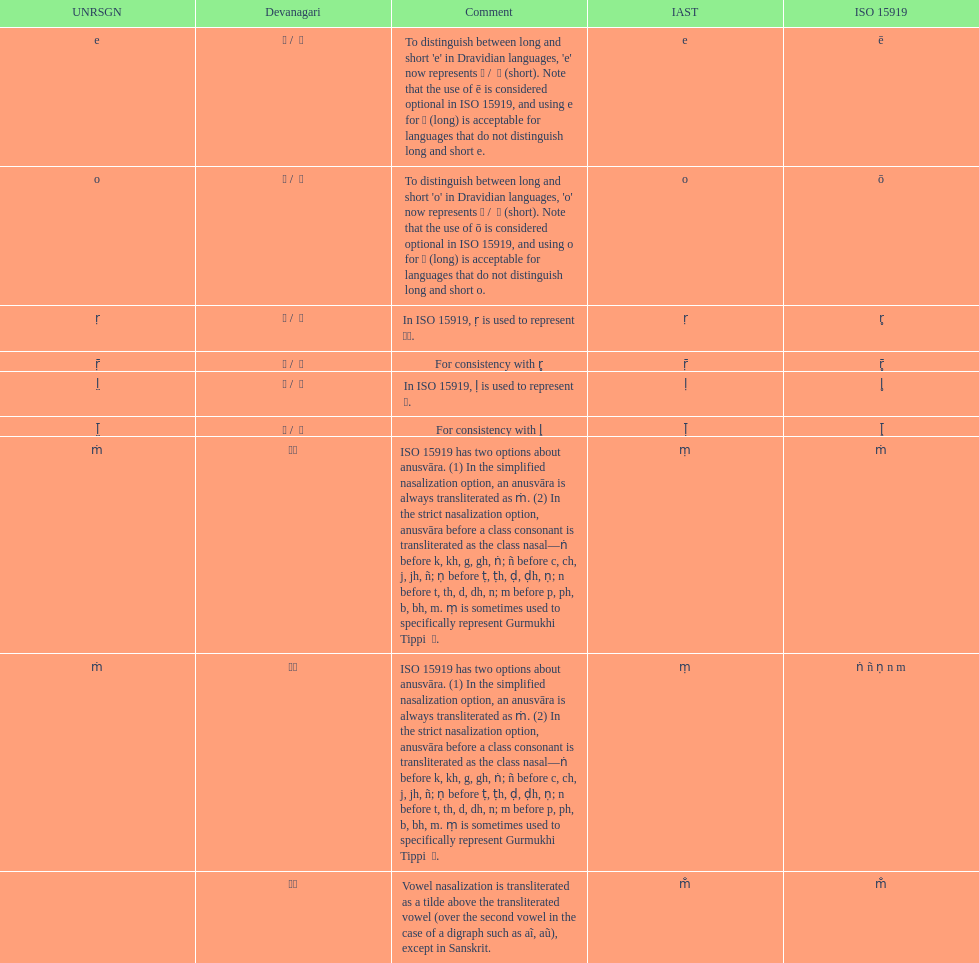Which devanagari transliteration is listed on the top of the table? ए / े. Give me the full table as a dictionary. {'header': ['UNRSGN', 'Devanagari', 'Comment', 'IAST', 'ISO 15919'], 'rows': [['e', 'ए / \xa0े', "To distinguish between long and short 'e' in Dravidian languages, 'e' now represents ऎ / \xa0ॆ (short). Note that the use of ē is considered optional in ISO 15919, and using e for ए (long) is acceptable for languages that do not distinguish long and short e.", 'e', 'ē'], ['o', 'ओ / \xa0ो', "To distinguish between long and short 'o' in Dravidian languages, 'o' now represents ऒ / \xa0ॊ (short). Note that the use of ō is considered optional in ISO 15919, and using o for ओ (long) is acceptable for languages that do not distinguish long and short o.", 'o', 'ō'], ['ṛ', 'ऋ / \xa0ृ', 'In ISO 15919, ṛ is used to represent ड़.', 'ṛ', 'r̥'], ['ṝ', 'ॠ / \xa0ॄ', 'For consistency with r̥', 'ṝ', 'r̥̄'], ['l̤', 'ऌ / \xa0ॢ', 'In ISO 15919, ḷ is used to represent ळ.', 'ḷ', 'l̥'], ['l̤̄', 'ॡ / \xa0ॣ', 'For consistency with l̥', 'ḹ', 'l̥̄'], ['ṁ', '◌ं', 'ISO 15919 has two options about anusvāra. (1) In the simplified nasalization option, an anusvāra is always transliterated as ṁ. (2) In the strict nasalization option, anusvāra before a class consonant is transliterated as the class nasal—ṅ before k, kh, g, gh, ṅ; ñ before c, ch, j, jh, ñ; ṇ before ṭ, ṭh, ḍ, ḍh, ṇ; n before t, th, d, dh, n; m before p, ph, b, bh, m. ṃ is sometimes used to specifically represent Gurmukhi Tippi \xa0ੰ.', 'ṃ', 'ṁ'], ['ṁ', '◌ं', 'ISO 15919 has two options about anusvāra. (1) In the simplified nasalization option, an anusvāra is always transliterated as ṁ. (2) In the strict nasalization option, anusvāra before a class consonant is transliterated as the class nasal—ṅ before k, kh, g, gh, ṅ; ñ before c, ch, j, jh, ñ; ṇ before ṭ, ṭh, ḍ, ḍh, ṇ; n before t, th, d, dh, n; m before p, ph, b, bh, m. ṃ is sometimes used to specifically represent Gurmukhi Tippi \xa0ੰ.', 'ṃ', 'ṅ ñ ṇ n m'], ['', '◌ँ', 'Vowel nasalization is transliterated as a tilde above the transliterated vowel (over the second vowel in the case of a digraph such as aĩ, aũ), except in Sanskrit.', 'm̐', 'm̐']]} 